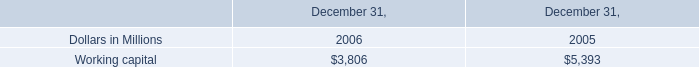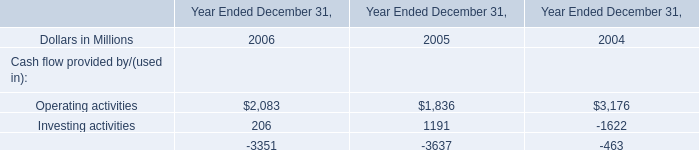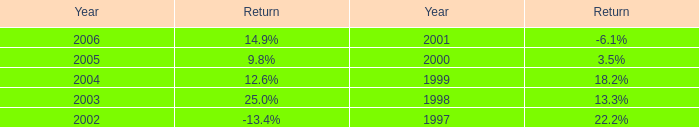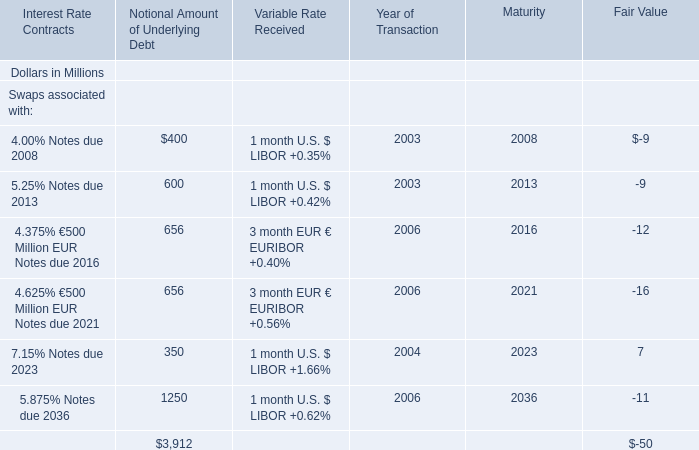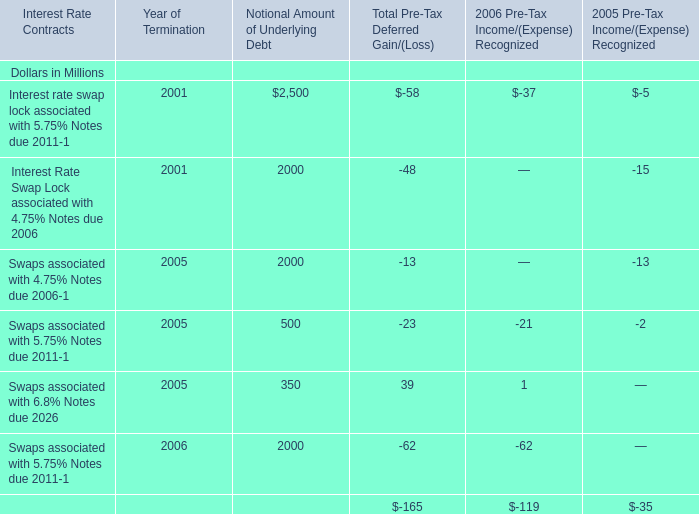What is the ratioof 4.00% Notes due 2008 to the total in 2003? 
Computations: (400 / (400 + 600))
Answer: 0.4. 